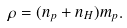Convert formula to latex. <formula><loc_0><loc_0><loc_500><loc_500>\rho = ( n _ { p } + n _ { H } ) m _ { p } .</formula> 